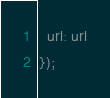Convert code to text. <code><loc_0><loc_0><loc_500><loc_500><_JavaScript_>  url: url
});</code> 